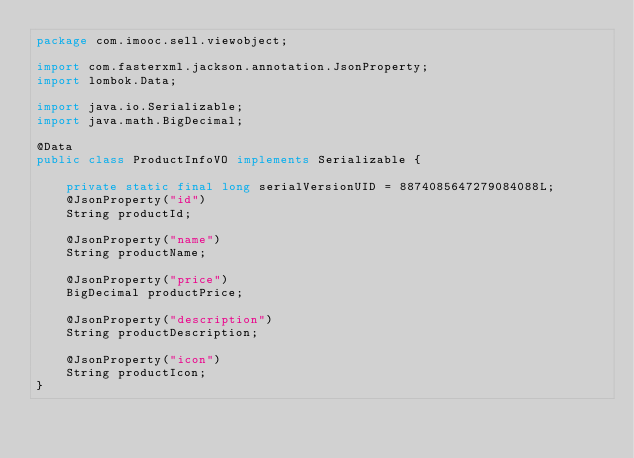Convert code to text. <code><loc_0><loc_0><loc_500><loc_500><_Java_>package com.imooc.sell.viewobject;

import com.fasterxml.jackson.annotation.JsonProperty;
import lombok.Data;

import java.io.Serializable;
import java.math.BigDecimal;

@Data
public class ProductInfoVO implements Serializable {

    private static final long serialVersionUID = 8874085647279084088L;
    @JsonProperty("id")
    String productId;

    @JsonProperty("name")
    String productName;

    @JsonProperty("price")
    BigDecimal productPrice;

    @JsonProperty("description")
    String productDescription;

    @JsonProperty("icon")
    String productIcon;
}
</code> 